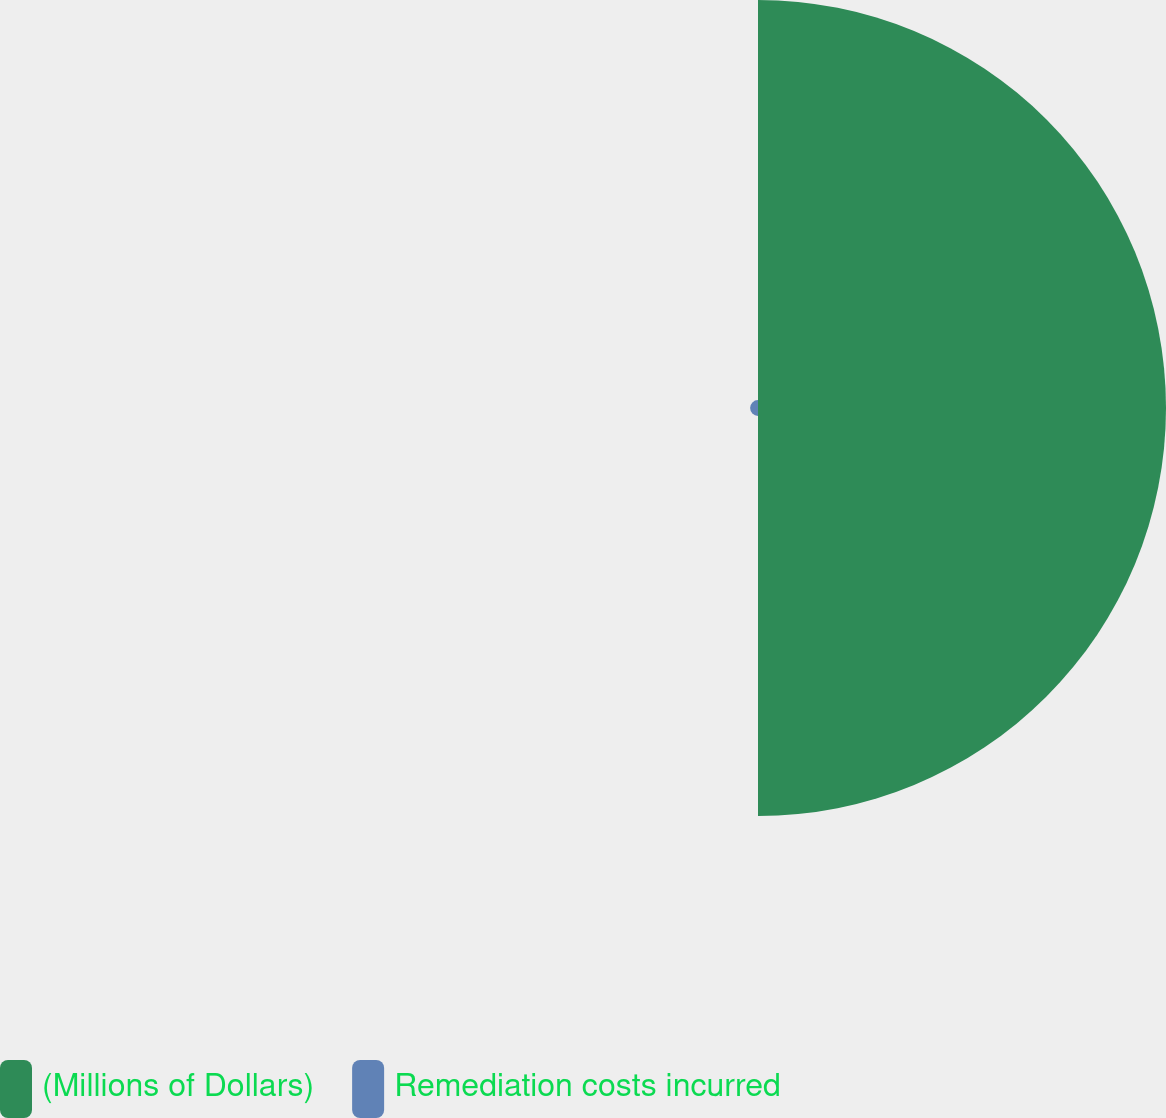<chart> <loc_0><loc_0><loc_500><loc_500><pie_chart><fcel>(Millions of Dollars)<fcel>Remediation costs incurred<nl><fcel>98.1%<fcel>1.9%<nl></chart> 